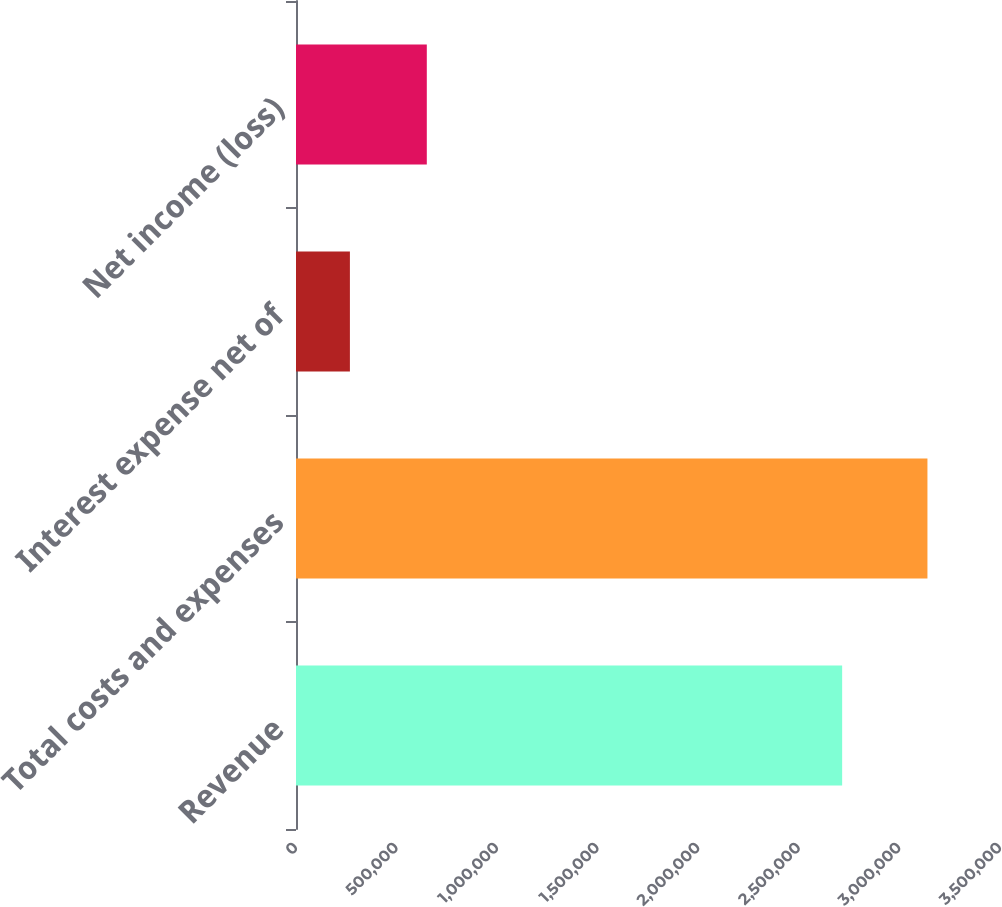Convert chart to OTSL. <chart><loc_0><loc_0><loc_500><loc_500><bar_chart><fcel>Revenue<fcel>Total costs and expenses<fcel>Interest expense net of<fcel>Net income (loss)<nl><fcel>2.71522e+06<fcel>3.13929e+06<fcel>267990<fcel>650326<nl></chart> 